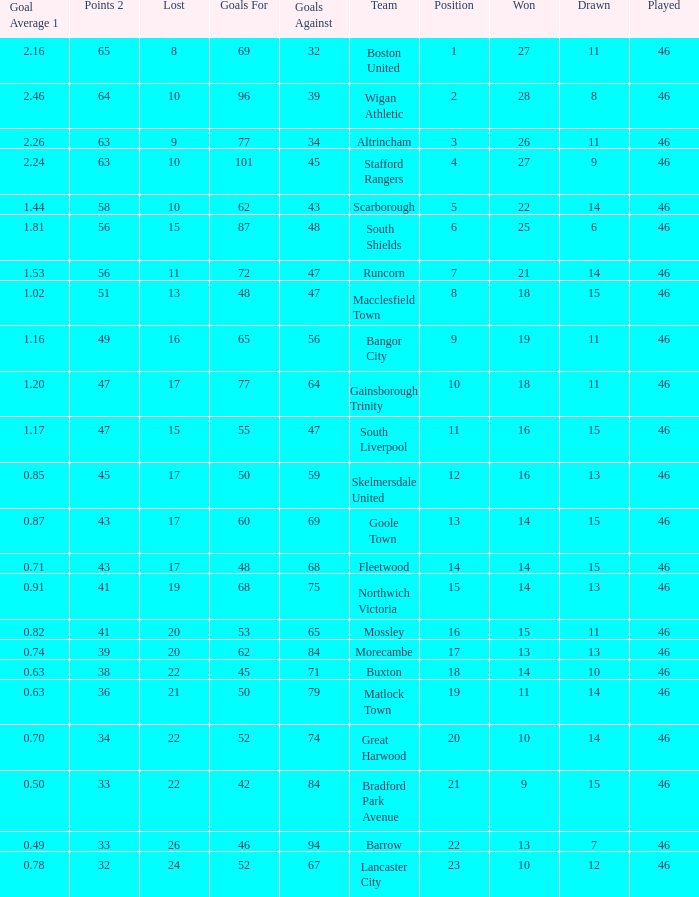How many games did the team who scored 60 goals win? 14.0. 